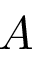<formula> <loc_0><loc_0><loc_500><loc_500>A</formula> 